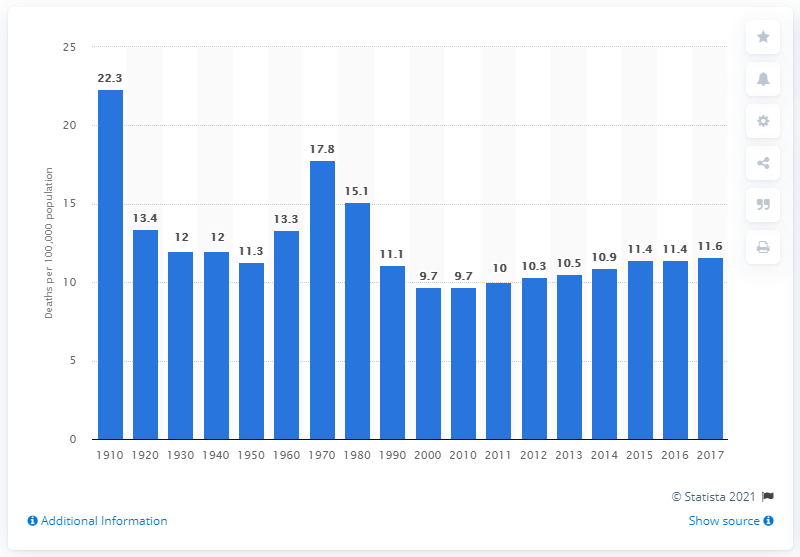Identify some key points in this picture. According to data from 2017, the death rate from liver cirrhosis was 11.6 per 100,000 individuals. 